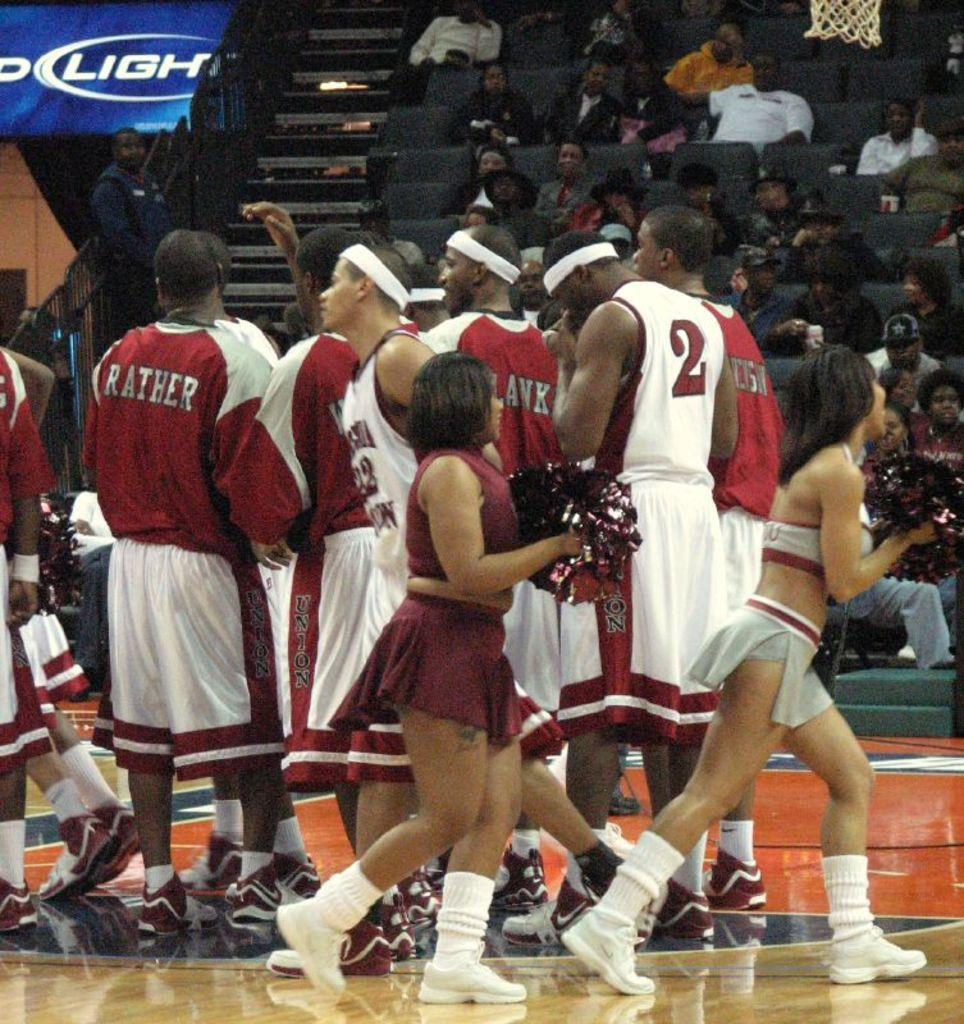Who or what can be seen in the image? There are people in the image. What can be seen in the background of the image? There are chairs, steps, and a hoarding in the background of the image. What is the role of the people in the image? The people are part of an audience. How does the fog affect the visibility of the cable in the image? There is no fog or cable present in the image. 